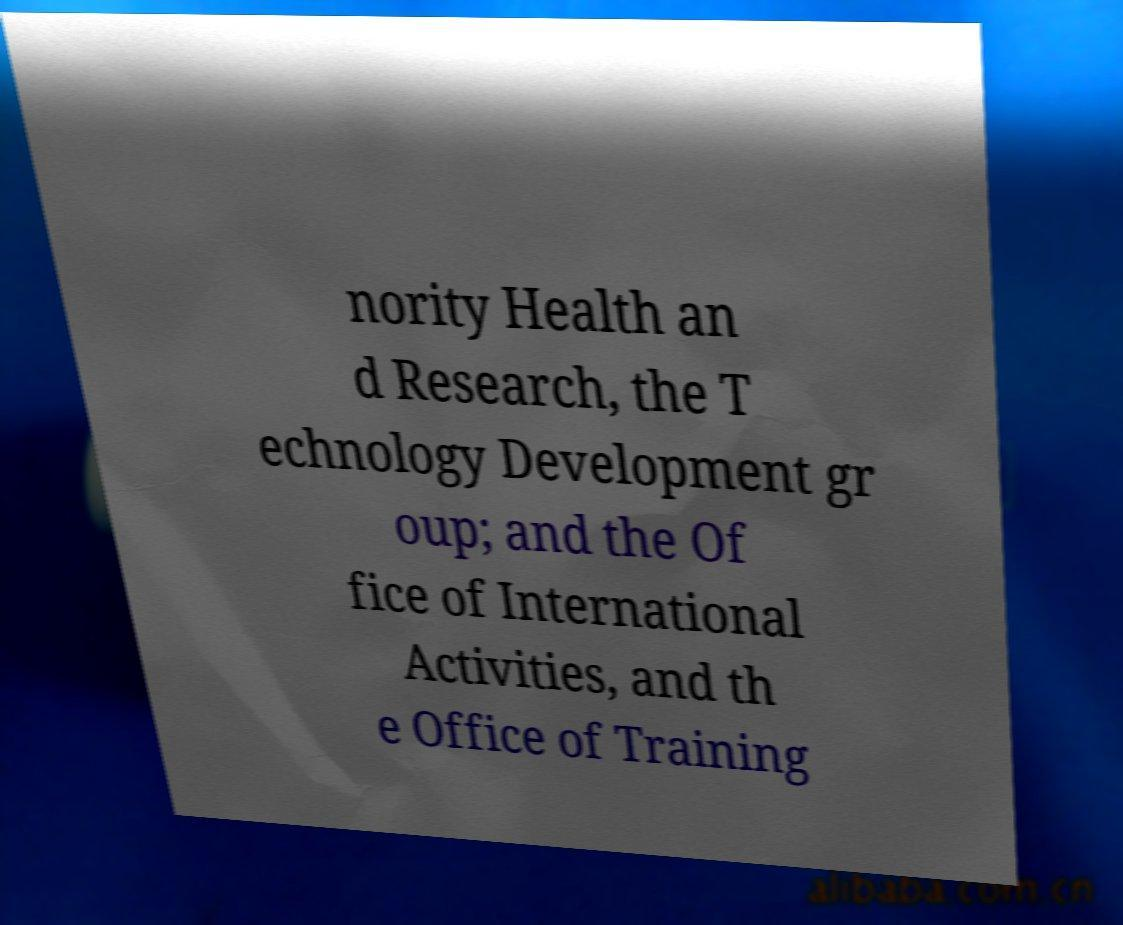For documentation purposes, I need the text within this image transcribed. Could you provide that? nority Health an d Research, the T echnology Development gr oup; and the Of fice of International Activities, and th e Office of Training 